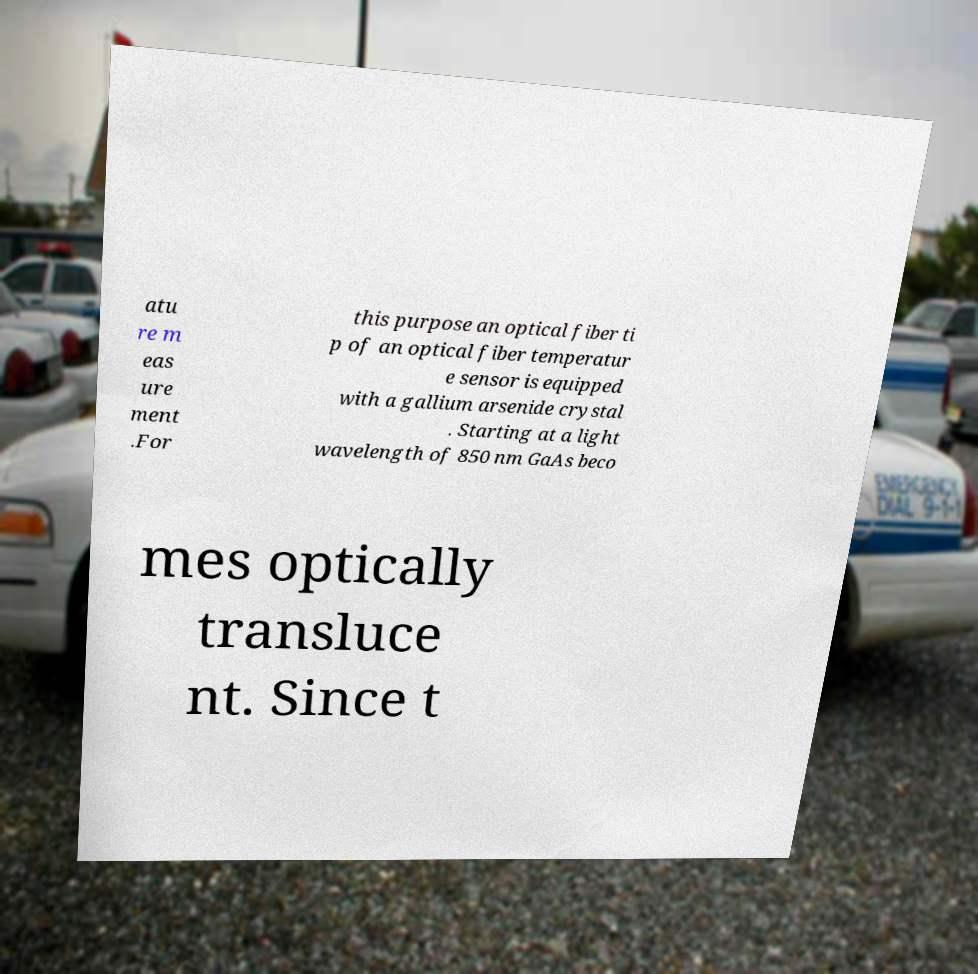I need the written content from this picture converted into text. Can you do that? atu re m eas ure ment .For this purpose an optical fiber ti p of an optical fiber temperatur e sensor is equipped with a gallium arsenide crystal . Starting at a light wavelength of 850 nm GaAs beco mes optically transluce nt. Since t 